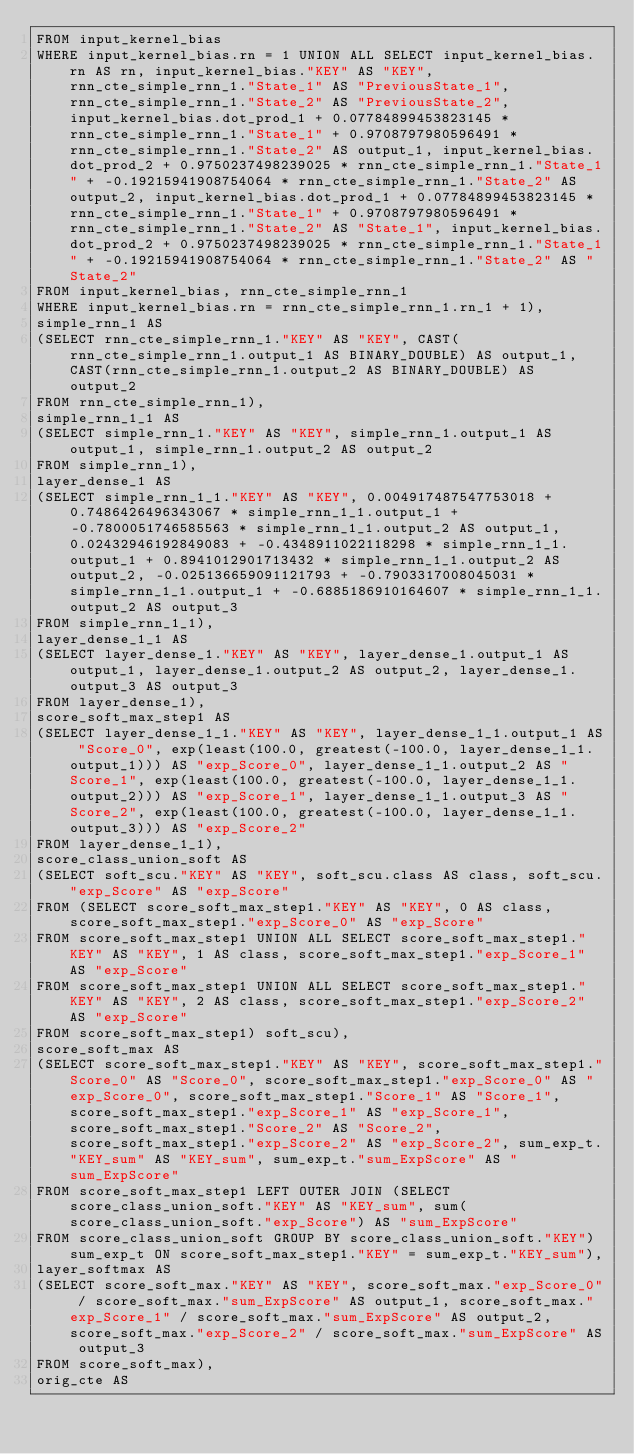Convert code to text. <code><loc_0><loc_0><loc_500><loc_500><_SQL_>FROM input_kernel_bias 
WHERE input_kernel_bias.rn = 1 UNION ALL SELECT input_kernel_bias.rn AS rn, input_kernel_bias."KEY" AS "KEY", rnn_cte_simple_rnn_1."State_1" AS "PreviousState_1", rnn_cte_simple_rnn_1."State_2" AS "PreviousState_2", input_kernel_bias.dot_prod_1 + 0.07784899453823145 * rnn_cte_simple_rnn_1."State_1" + 0.9708797980596491 * rnn_cte_simple_rnn_1."State_2" AS output_1, input_kernel_bias.dot_prod_2 + 0.9750237498239025 * rnn_cte_simple_rnn_1."State_1" + -0.19215941908754064 * rnn_cte_simple_rnn_1."State_2" AS output_2, input_kernel_bias.dot_prod_1 + 0.07784899453823145 * rnn_cte_simple_rnn_1."State_1" + 0.9708797980596491 * rnn_cte_simple_rnn_1."State_2" AS "State_1", input_kernel_bias.dot_prod_2 + 0.9750237498239025 * rnn_cte_simple_rnn_1."State_1" + -0.19215941908754064 * rnn_cte_simple_rnn_1."State_2" AS "State_2" 
FROM input_kernel_bias, rnn_cte_simple_rnn_1 
WHERE input_kernel_bias.rn = rnn_cte_simple_rnn_1.rn_1 + 1), 
simple_rnn_1 AS 
(SELECT rnn_cte_simple_rnn_1."KEY" AS "KEY", CAST(rnn_cte_simple_rnn_1.output_1 AS BINARY_DOUBLE) AS output_1, CAST(rnn_cte_simple_rnn_1.output_2 AS BINARY_DOUBLE) AS output_2 
FROM rnn_cte_simple_rnn_1), 
simple_rnn_1_1 AS 
(SELECT simple_rnn_1."KEY" AS "KEY", simple_rnn_1.output_1 AS output_1, simple_rnn_1.output_2 AS output_2 
FROM simple_rnn_1), 
layer_dense_1 AS 
(SELECT simple_rnn_1_1."KEY" AS "KEY", 0.004917487547753018 + 0.7486426496343067 * simple_rnn_1_1.output_1 + -0.7800051746585563 * simple_rnn_1_1.output_2 AS output_1, 0.02432946192849083 + -0.4348911022118298 * simple_rnn_1_1.output_1 + 0.8941012901713432 * simple_rnn_1_1.output_2 AS output_2, -0.025136659091121793 + -0.7903317008045031 * simple_rnn_1_1.output_1 + -0.6885186910164607 * simple_rnn_1_1.output_2 AS output_3 
FROM simple_rnn_1_1), 
layer_dense_1_1 AS 
(SELECT layer_dense_1."KEY" AS "KEY", layer_dense_1.output_1 AS output_1, layer_dense_1.output_2 AS output_2, layer_dense_1.output_3 AS output_3 
FROM layer_dense_1), 
score_soft_max_step1 AS 
(SELECT layer_dense_1_1."KEY" AS "KEY", layer_dense_1_1.output_1 AS "Score_0", exp(least(100.0, greatest(-100.0, layer_dense_1_1.output_1))) AS "exp_Score_0", layer_dense_1_1.output_2 AS "Score_1", exp(least(100.0, greatest(-100.0, layer_dense_1_1.output_2))) AS "exp_Score_1", layer_dense_1_1.output_3 AS "Score_2", exp(least(100.0, greatest(-100.0, layer_dense_1_1.output_3))) AS "exp_Score_2" 
FROM layer_dense_1_1), 
score_class_union_soft AS 
(SELECT soft_scu."KEY" AS "KEY", soft_scu.class AS class, soft_scu."exp_Score" AS "exp_Score" 
FROM (SELECT score_soft_max_step1."KEY" AS "KEY", 0 AS class, score_soft_max_step1."exp_Score_0" AS "exp_Score" 
FROM score_soft_max_step1 UNION ALL SELECT score_soft_max_step1."KEY" AS "KEY", 1 AS class, score_soft_max_step1."exp_Score_1" AS "exp_Score" 
FROM score_soft_max_step1 UNION ALL SELECT score_soft_max_step1."KEY" AS "KEY", 2 AS class, score_soft_max_step1."exp_Score_2" AS "exp_Score" 
FROM score_soft_max_step1) soft_scu), 
score_soft_max AS 
(SELECT score_soft_max_step1."KEY" AS "KEY", score_soft_max_step1."Score_0" AS "Score_0", score_soft_max_step1."exp_Score_0" AS "exp_Score_0", score_soft_max_step1."Score_1" AS "Score_1", score_soft_max_step1."exp_Score_1" AS "exp_Score_1", score_soft_max_step1."Score_2" AS "Score_2", score_soft_max_step1."exp_Score_2" AS "exp_Score_2", sum_exp_t."KEY_sum" AS "KEY_sum", sum_exp_t."sum_ExpScore" AS "sum_ExpScore" 
FROM score_soft_max_step1 LEFT OUTER JOIN (SELECT score_class_union_soft."KEY" AS "KEY_sum", sum(score_class_union_soft."exp_Score") AS "sum_ExpScore" 
FROM score_class_union_soft GROUP BY score_class_union_soft."KEY") sum_exp_t ON score_soft_max_step1."KEY" = sum_exp_t."KEY_sum"), 
layer_softmax AS 
(SELECT score_soft_max."KEY" AS "KEY", score_soft_max."exp_Score_0" / score_soft_max."sum_ExpScore" AS output_1, score_soft_max."exp_Score_1" / score_soft_max."sum_ExpScore" AS output_2, score_soft_max."exp_Score_2" / score_soft_max."sum_ExpScore" AS output_3 
FROM score_soft_max), 
orig_cte AS </code> 